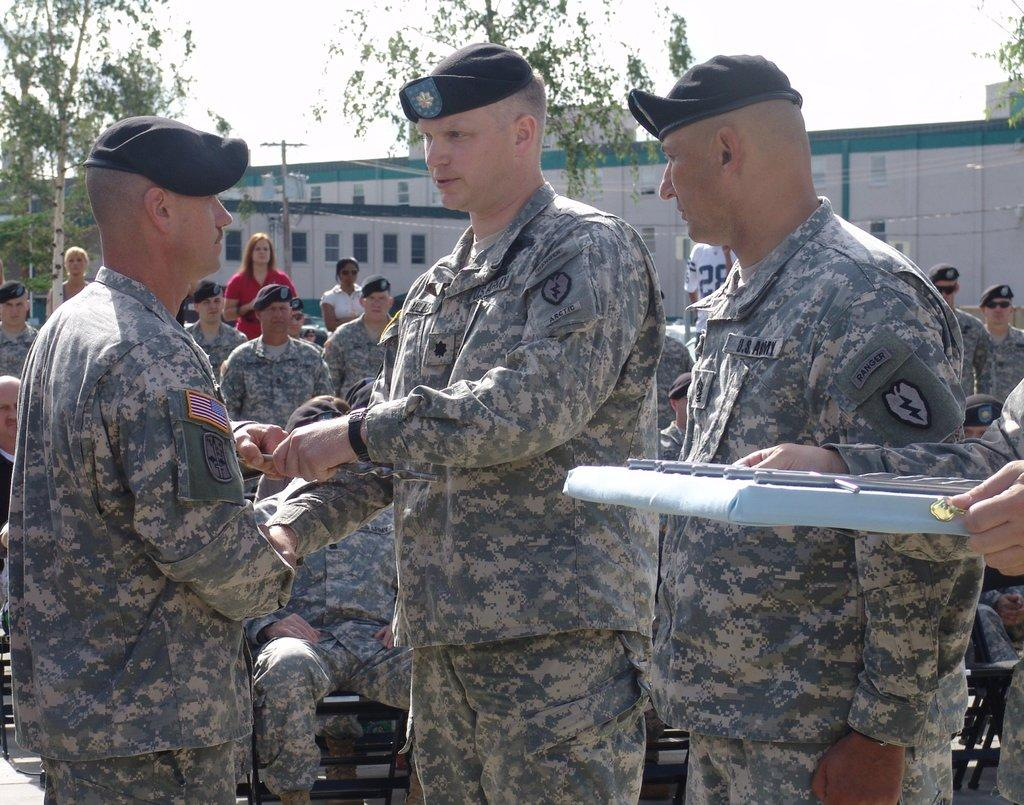What are the persons in the image wearing? The persons in the image are wearing uniforms. What are the persons in the image doing? Some of the persons are standing, while others are sitting. What can be seen in the background of the image? There are trees, a pole, a building, and the sky visible in the background of the image. What type of zinc is present in the image? There is no zinc present in the image. Can you tell me which person in the image is the father? The image does not provide any information about the relationships between the persons, so it is not possible to determine who the father is. 